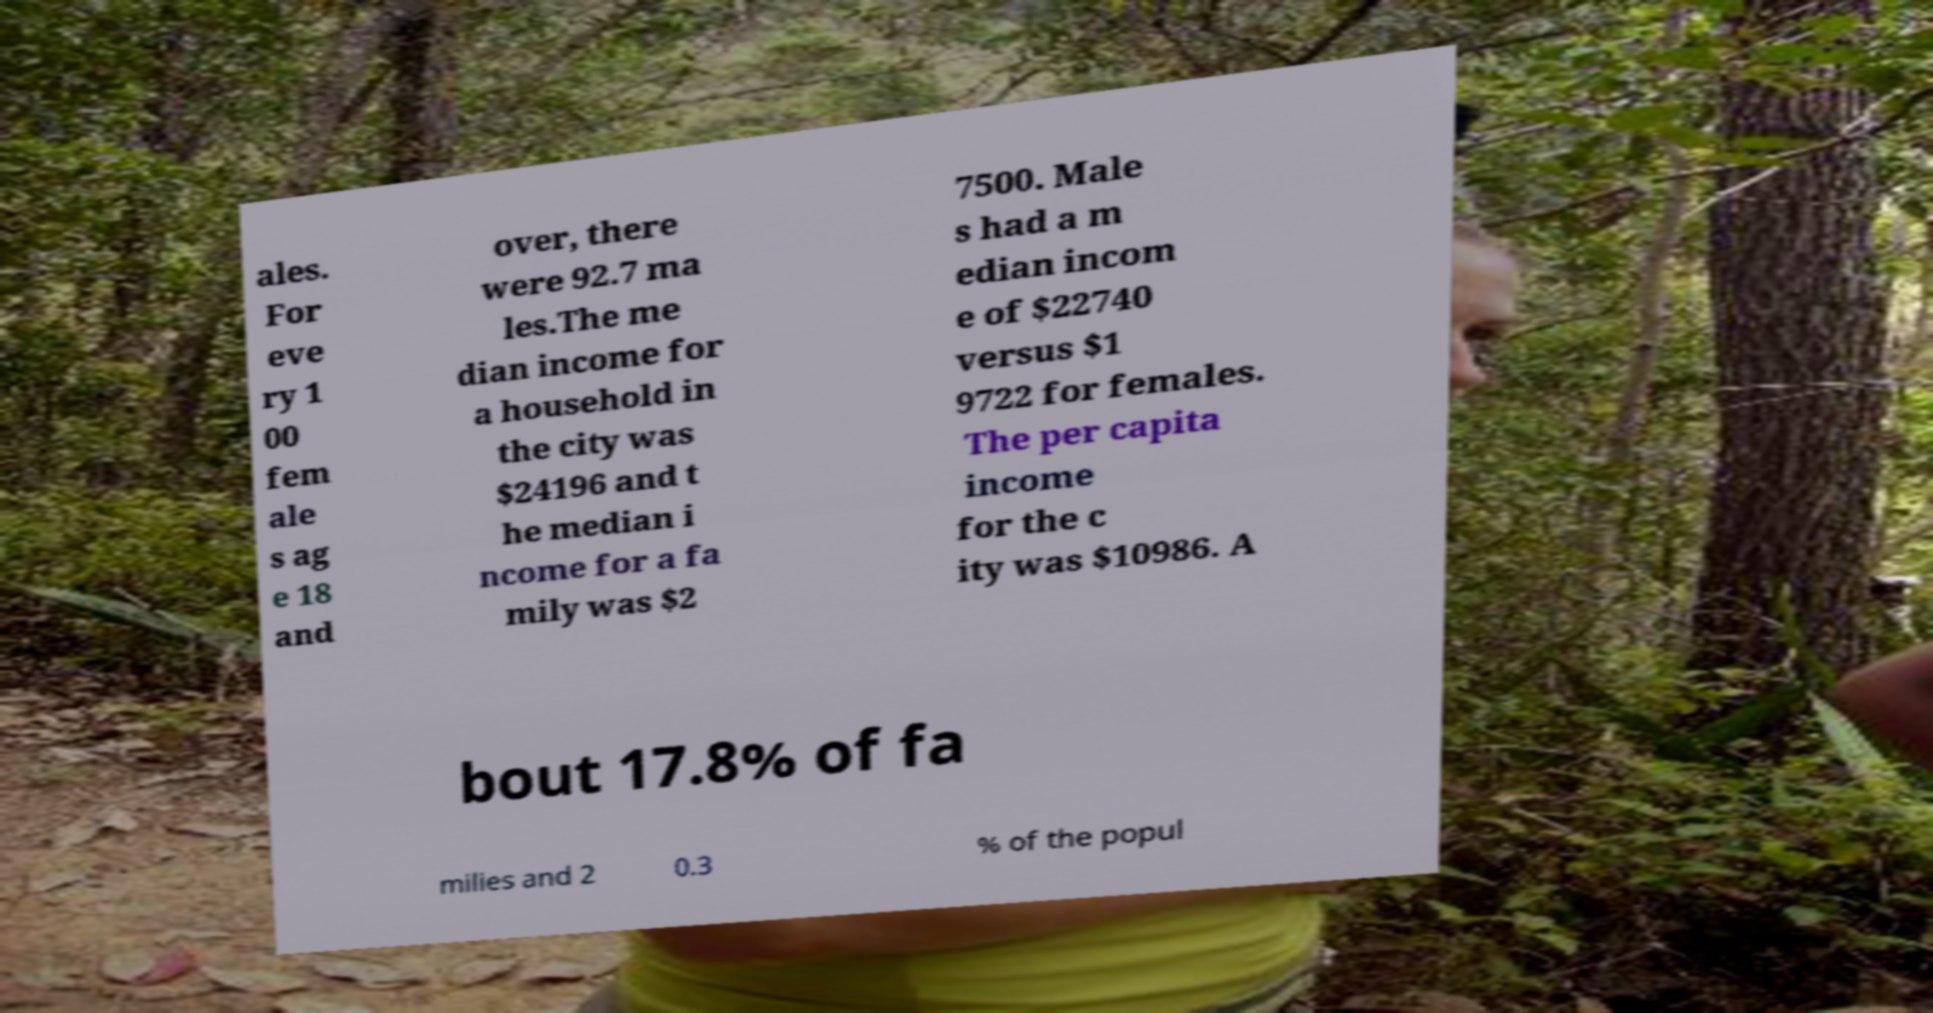Can you accurately transcribe the text from the provided image for me? ales. For eve ry 1 00 fem ale s ag e 18 and over, there were 92.7 ma les.The me dian income for a household in the city was $24196 and t he median i ncome for a fa mily was $2 7500. Male s had a m edian incom e of $22740 versus $1 9722 for females. The per capita income for the c ity was $10986. A bout 17.8% of fa milies and 2 0.3 % of the popul 